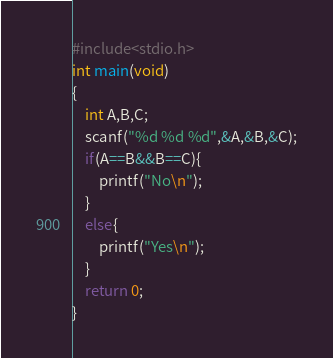Convert code to text. <code><loc_0><loc_0><loc_500><loc_500><_C_>#include<stdio.h>
int main(void)
{
	int A,B,C;
	scanf("%d %d %d",&A,&B,&C);
	if(A==B&&B==C){
		printf("No\n");
	}
	else{
		printf("Yes\n");
	}
	return 0;
}</code> 